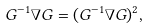Convert formula to latex. <formula><loc_0><loc_0><loc_500><loc_500>G ^ { - 1 } \nabla G = ( G ^ { - 1 } \nabla G ) ^ { 2 } ,</formula> 